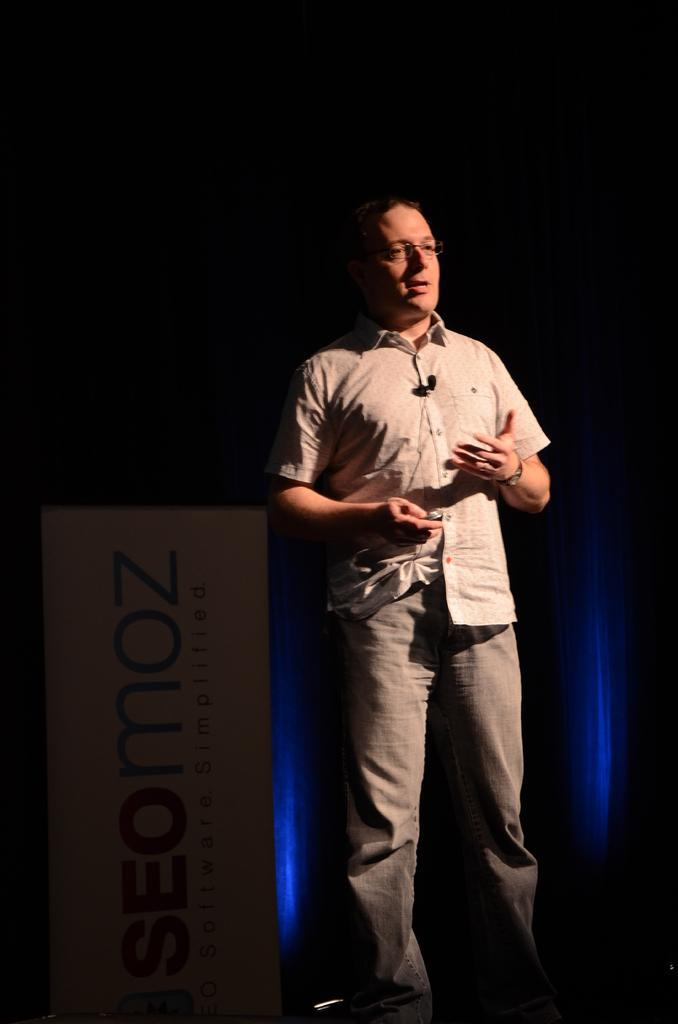What is the main subject in the center of the image? There is a man standing in the center of the image. What can be seen in the background area? There is a poster and a curtain in the background area. How many times does the man smile in the image? The provided facts do not mention the man's facial expression, so we cannot determine if he is smiling or not. 